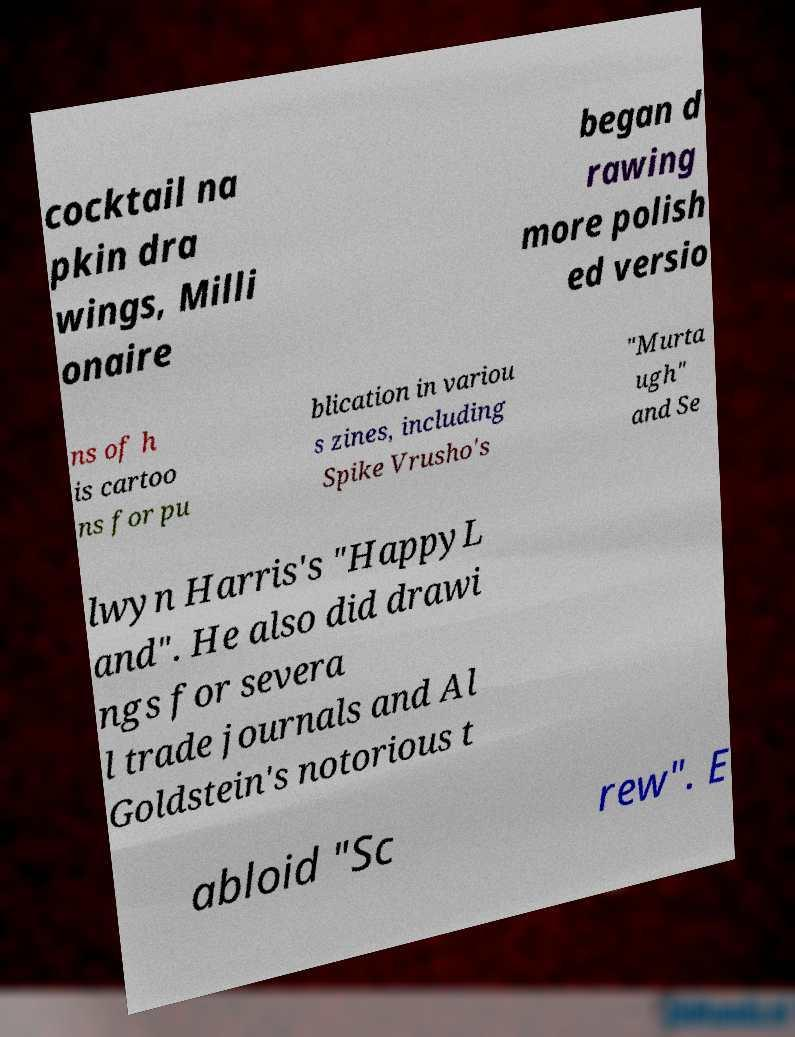Could you extract and type out the text from this image? cocktail na pkin dra wings, Milli onaire began d rawing more polish ed versio ns of h is cartoo ns for pu blication in variou s zines, including Spike Vrusho's "Murta ugh" and Se lwyn Harris's "HappyL and". He also did drawi ngs for severa l trade journals and Al Goldstein's notorious t abloid "Sc rew". E 